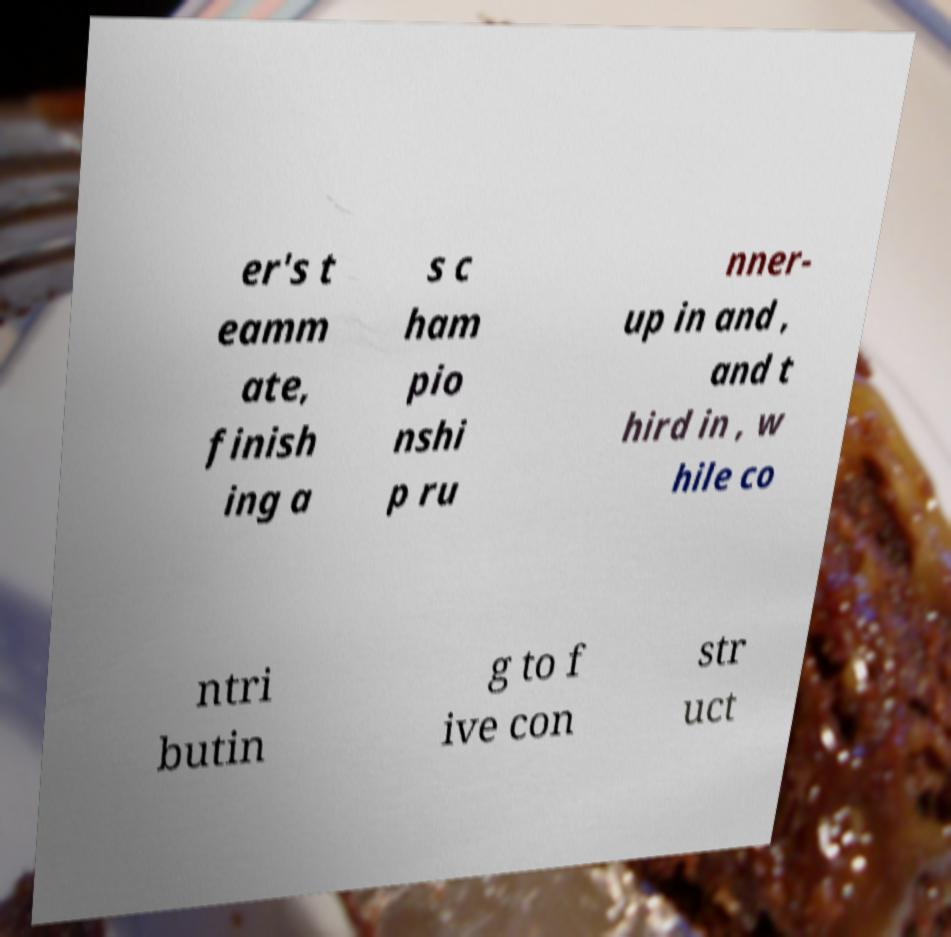Please identify and transcribe the text found in this image. er's t eamm ate, finish ing a s c ham pio nshi p ru nner- up in and , and t hird in , w hile co ntri butin g to f ive con str uct 